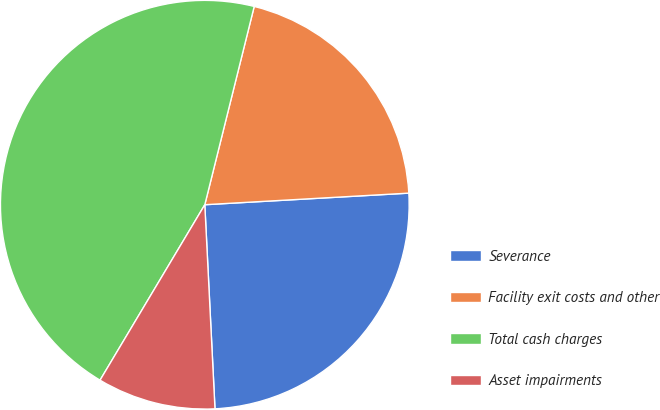Convert chart. <chart><loc_0><loc_0><loc_500><loc_500><pie_chart><fcel>Severance<fcel>Facility exit costs and other<fcel>Total cash charges<fcel>Asset impairments<nl><fcel>25.11%<fcel>20.21%<fcel>45.32%<fcel>9.36%<nl></chart> 